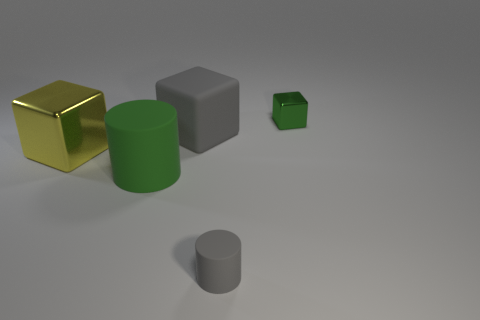What number of other things are the same color as the big rubber cylinder?
Your response must be concise. 1. There is a green thing left of the gray cylinder; is its shape the same as the small gray thing?
Offer a terse response. Yes. What is the color of the other thing that is the same shape as the large green matte thing?
Your response must be concise. Gray. There is another object that is the same shape as the large green rubber thing; what size is it?
Your answer should be very brief. Small. What is the material of the thing that is both right of the big gray rubber thing and behind the large yellow metal object?
Give a very brief answer. Metal. There is a tiny object that is in front of the tiny green block; is it the same color as the large matte cube?
Offer a terse response. Yes. Do the large rubber cylinder and the shiny block that is to the right of the green matte cylinder have the same color?
Your response must be concise. Yes. Are there any metallic things in front of the small green block?
Make the answer very short. Yes. Do the green cylinder and the small green thing have the same material?
Keep it short and to the point. No. What material is the gray thing that is the same size as the green matte object?
Your answer should be compact. Rubber. 